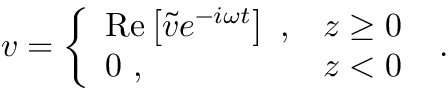Convert formula to latex. <formula><loc_0><loc_0><loc_500><loc_500>v = \left \{ \begin{array} { l l } { R e \left [ \tilde { v } e ^ { - i \omega t } \right ] , } & { z \geq 0 } \\ { 0 , } & { z < 0 } \end{array} .</formula> 